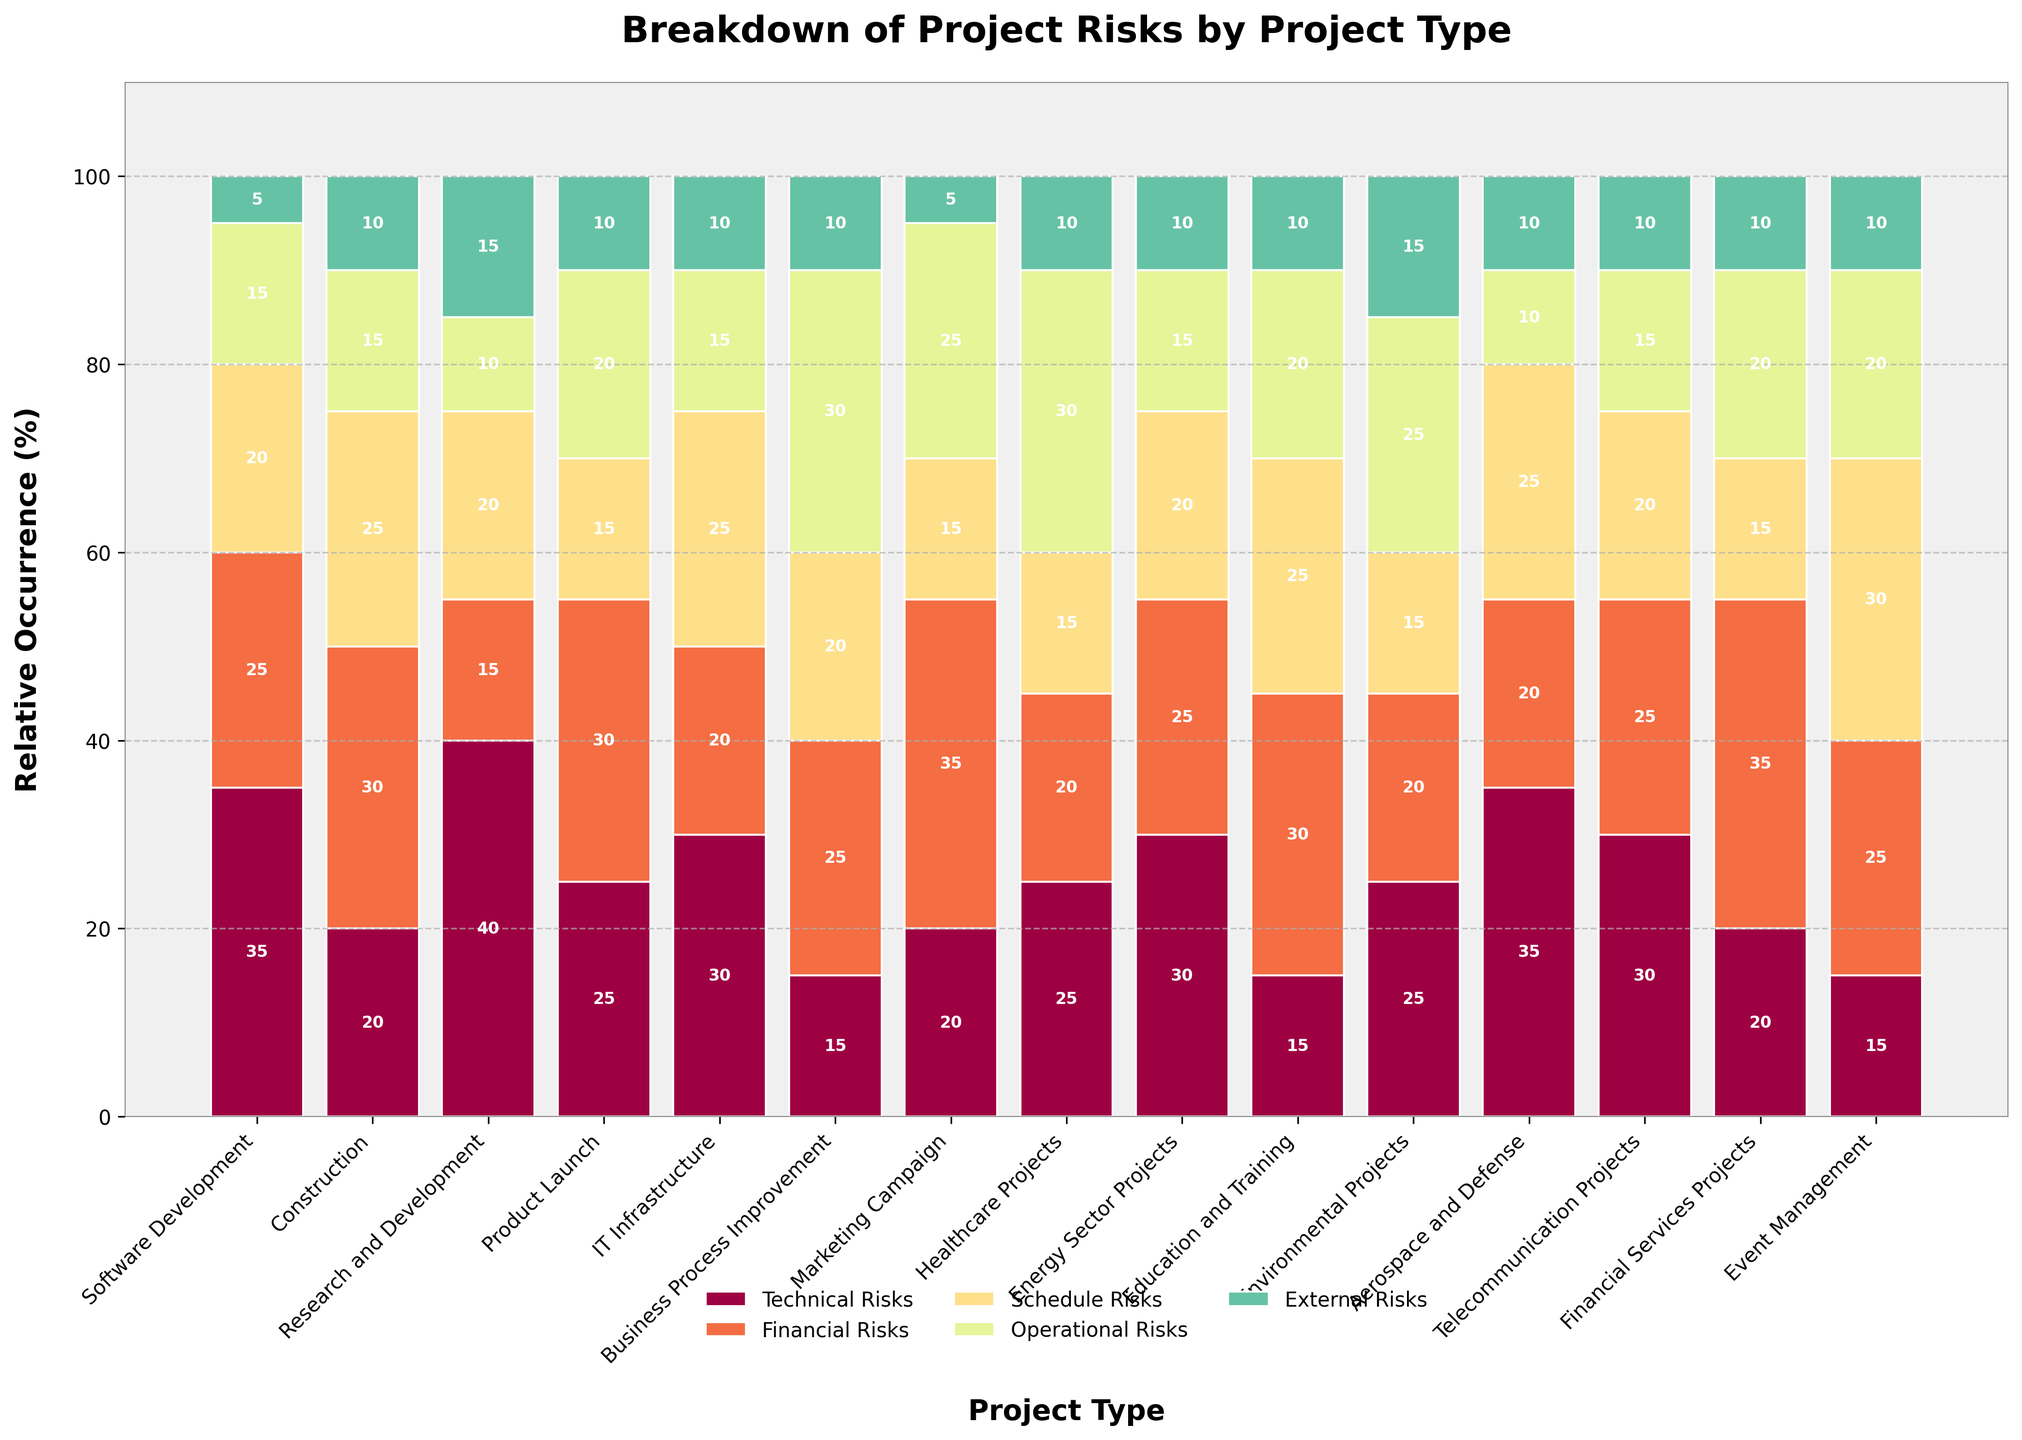Which project type has the highest occurrence of technical risks? To determine this, look for the bar segment representing technical risks across all project types. The highest bar segment corresponds to Research and Development projects.
Answer: Research and Development Which project type has the lowest total occurrence of risks? Sum all the risk occurrences for each project type and compare them. The project type with the lowest sum is Event Management with a total of 100%.
Answer: Event Management What is the total occurrence of financial risks in Construction and Healthcare Projects combined? Find the financial risk values for both project types: Construction (30%) and Healthcare Projects (20%). Add them together to get the combined total: 30% + 20% = 50%.
Answer: 50% Which project type has a higher occurrence of operational risks: Marketing Campaign or Business Process Improvement? Compare the bar segments of operational risks for the two types: Marketing Campaign (25%) and Business Process Improvement (30%). Business Process Improvement has a higher occurrence.
Answer: Business Process Improvement Compare the occurrence of schedule risks in Software Development and Financial Services Projects. Which one is higher? Look at the value for schedule risks: Software Development (20%) and Financial Services Projects (15%). Software Development has a higher occurrence.
Answer: Software Development Calculate the average occurrence of external risks across all project types. Sum the external risks percentages across all project types (5 + 10 + 15 + 10 + 10 + 10 + 5 + 10 + 10 + 10 + 15 + 10 + 10 + 10 + 10) = 140. Then, divide by the number of project types (15), resulting in 140 / 15 ≈ 9.33%.
Answer: 9.33% Which project type has the largest difference between financial and technical risks? Calculate the difference between financial and technical risks for each project type, and find the largest difference. Financial Services Projects have the largest difference of 15% (35% financial - 20% technical).
Answer: Financial Services Projects In which project type does the sum of schedule and operational risks exceed 50%? Add the values of schedule and operational risks for each project type and identify any sums exceeding 50%. Event Management has 30% schedule and 20% operational, totaling 50%, which doesn't exceed. Other sums do not exceed 50% either.
Answer: None By how much does the occurrence of financial risks in Marketing Campaign projects exceed the occurrence of financial risks in Software Development projects? Compare the financial risks values: Marketing Campaign (35%) and Software Development (25%). Subtract to find the excess: 35% - 25% = 10%.
Answer: 10% Which project type has a more balanced distribution of risks, with less variation between different risk types? Evaluate the risk distribution for each project type, looking for relatively equal bars. Education and Training projects have a balanced distribution (15%, 30%, 25%, 20%, 10%).
Answer: Education and Training 